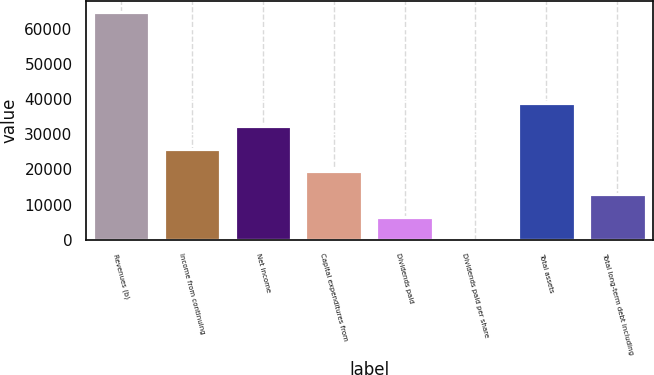<chart> <loc_0><loc_0><loc_500><loc_500><bar_chart><fcel>Revenues (b)<fcel>Income from continuing<fcel>Net income<fcel>Capital expenditures from<fcel>Dividends paid<fcel>Dividends paid per share<fcel>Total assets<fcel>Total long-term debt including<nl><fcel>64896<fcel>25959.3<fcel>32448.8<fcel>19469.9<fcel>6490.98<fcel>1.53<fcel>38938.2<fcel>12980.4<nl></chart> 